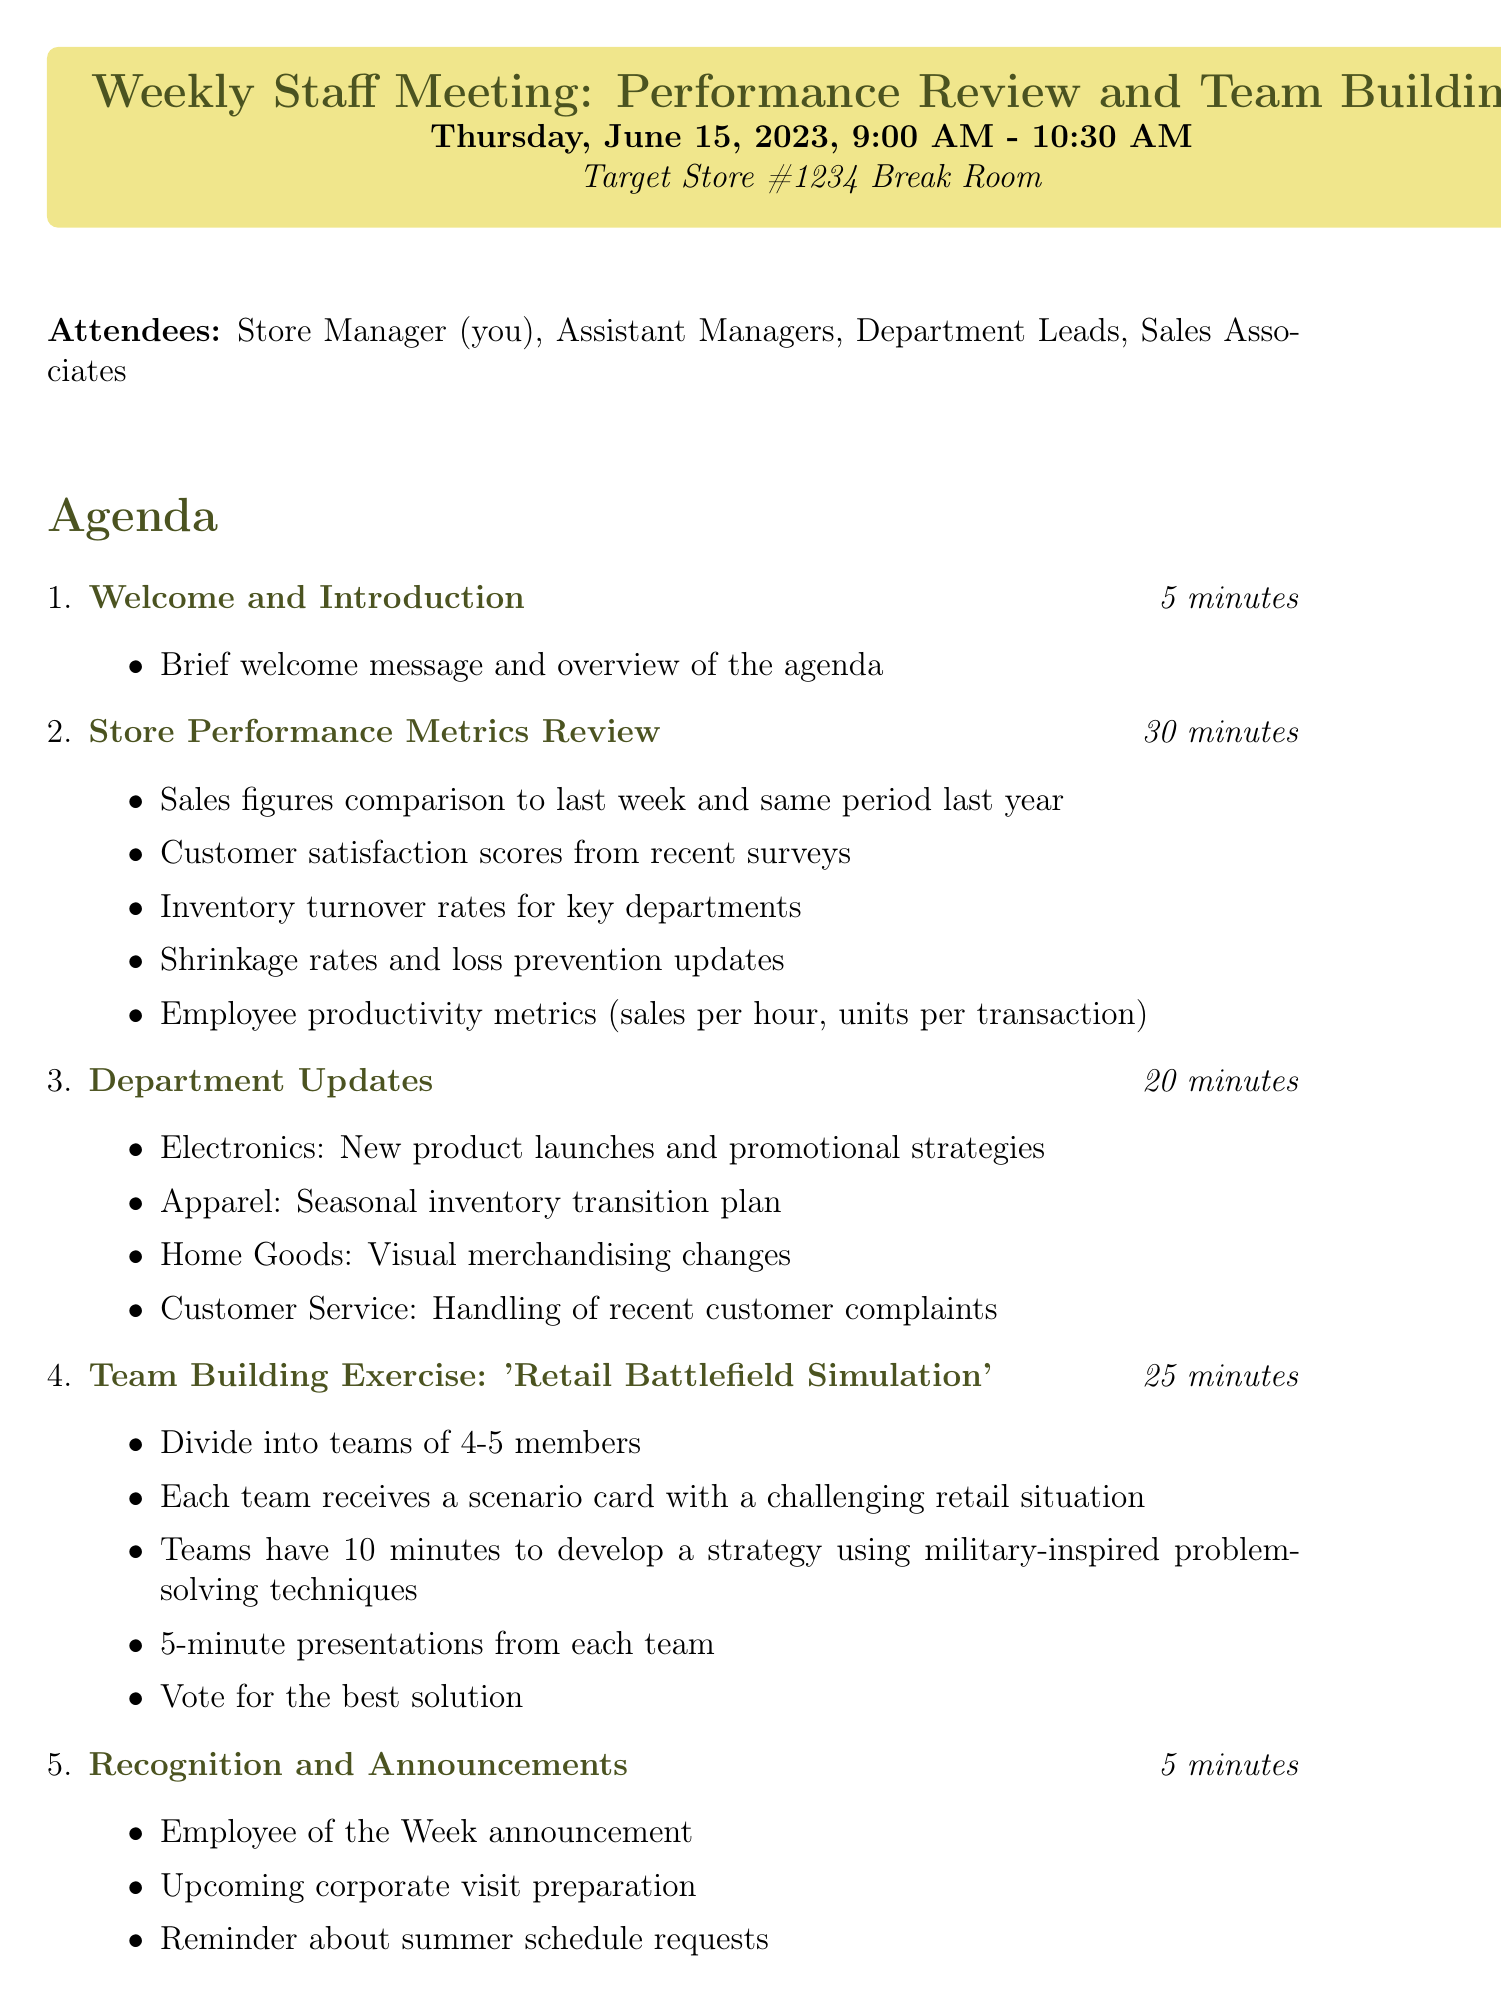What is the date and time of the meeting? The date and time of the meeting is mentioned at the beginning of the document.
Answer: Thursday, June 15, 2023, 9:00 AM - 10:30 AM How long is the Store Performance Metrics Review scheduled for? The duration of each agenda item is specified in minutes.
Answer: 30 minutes What is one key metric discussed during the performance review? The document lists several performance metrics under the Store Performance Metrics Review section.
Answer: Sales figures What exercise is being conducted for team building? The document includes details about a specific team-building exercise.
Answer: Retail Battlefield Simulation Who is responsible for distributing the meeting minutes? The follow-up actions section indicates who will perform this task.
Answer: Store Manager How many attendees are there in total? The document lists the attendees and their roles, which can be counted.
Answer: 4 What will the teams do in the team-building exercise? The agenda outlines specific tasks teams must complete during the exercise.
Answer: Develop a strategy Which department is responsible for handling recent customer complaints? The document mentions department updates along with their responsibilities.
Answer: Customer Service What is one of the materials needed for the meeting? The materials needed are listed in the agenda.
Answer: Performance metrics printouts 